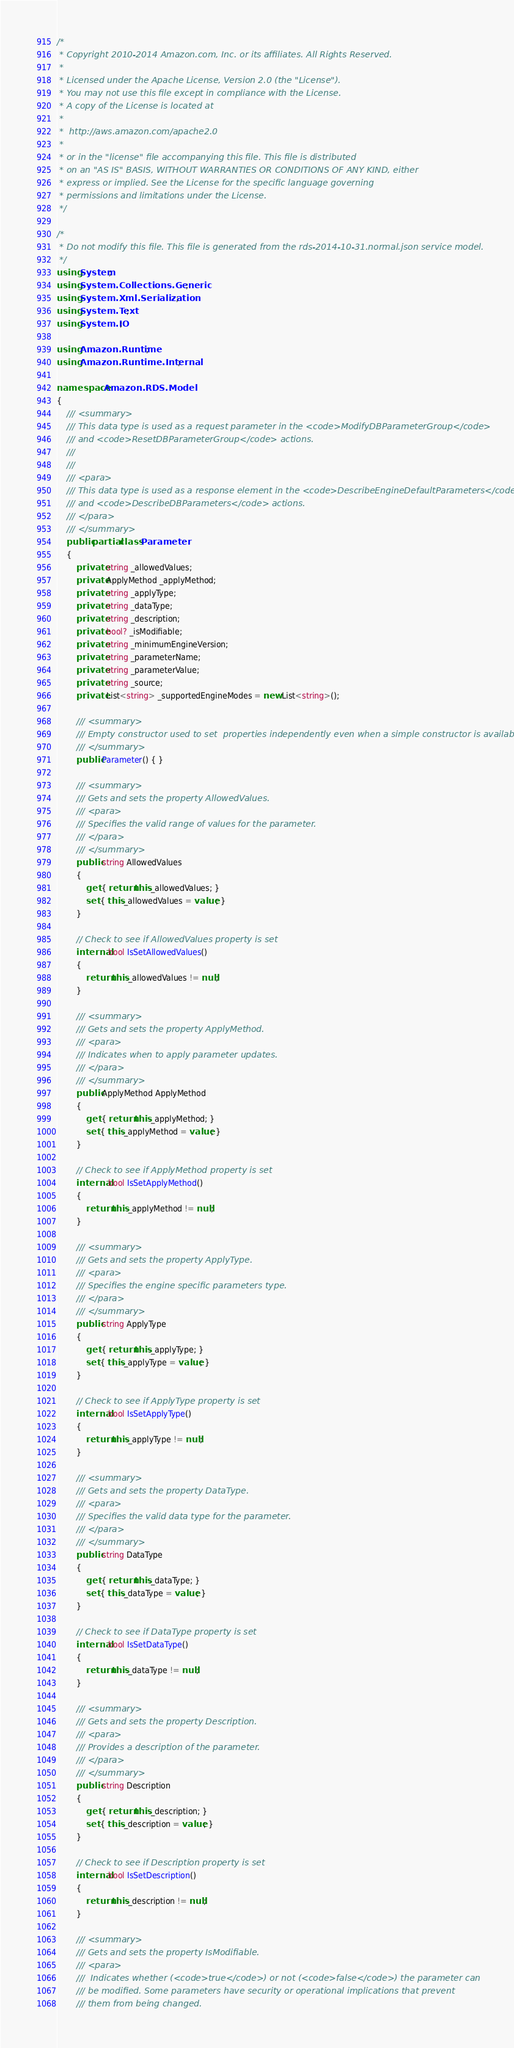<code> <loc_0><loc_0><loc_500><loc_500><_C#_>/*
 * Copyright 2010-2014 Amazon.com, Inc. or its affiliates. All Rights Reserved.
 * 
 * Licensed under the Apache License, Version 2.0 (the "License").
 * You may not use this file except in compliance with the License.
 * A copy of the License is located at
 * 
 *  http://aws.amazon.com/apache2.0
 * 
 * or in the "license" file accompanying this file. This file is distributed
 * on an "AS IS" BASIS, WITHOUT WARRANTIES OR CONDITIONS OF ANY KIND, either
 * express or implied. See the License for the specific language governing
 * permissions and limitations under the License.
 */

/*
 * Do not modify this file. This file is generated from the rds-2014-10-31.normal.json service model.
 */
using System;
using System.Collections.Generic;
using System.Xml.Serialization;
using System.Text;
using System.IO;

using Amazon.Runtime;
using Amazon.Runtime.Internal;

namespace Amazon.RDS.Model
{
    /// <summary>
    /// This data type is used as a request parameter in the <code>ModifyDBParameterGroup</code>
    /// and <code>ResetDBParameterGroup</code> actions. 
    /// 
    ///  
    /// <para>
    /// This data type is used as a response element in the <code>DescribeEngineDefaultParameters</code>
    /// and <code>DescribeDBParameters</code> actions.
    /// </para>
    /// </summary>
    public partial class Parameter
    {
        private string _allowedValues;
        private ApplyMethod _applyMethod;
        private string _applyType;
        private string _dataType;
        private string _description;
        private bool? _isModifiable;
        private string _minimumEngineVersion;
        private string _parameterName;
        private string _parameterValue;
        private string _source;
        private List<string> _supportedEngineModes = new List<string>();

        /// <summary>
        /// Empty constructor used to set  properties independently even when a simple constructor is available
        /// </summary>
        public Parameter() { }

        /// <summary>
        /// Gets and sets the property AllowedValues. 
        /// <para>
        /// Specifies the valid range of values for the parameter.
        /// </para>
        /// </summary>
        public string AllowedValues
        {
            get { return this._allowedValues; }
            set { this._allowedValues = value; }
        }

        // Check to see if AllowedValues property is set
        internal bool IsSetAllowedValues()
        {
            return this._allowedValues != null;
        }

        /// <summary>
        /// Gets and sets the property ApplyMethod. 
        /// <para>
        /// Indicates when to apply parameter updates.
        /// </para>
        /// </summary>
        public ApplyMethod ApplyMethod
        {
            get { return this._applyMethod; }
            set { this._applyMethod = value; }
        }

        // Check to see if ApplyMethod property is set
        internal bool IsSetApplyMethod()
        {
            return this._applyMethod != null;
        }

        /// <summary>
        /// Gets and sets the property ApplyType. 
        /// <para>
        /// Specifies the engine specific parameters type.
        /// </para>
        /// </summary>
        public string ApplyType
        {
            get { return this._applyType; }
            set { this._applyType = value; }
        }

        // Check to see if ApplyType property is set
        internal bool IsSetApplyType()
        {
            return this._applyType != null;
        }

        /// <summary>
        /// Gets and sets the property DataType. 
        /// <para>
        /// Specifies the valid data type for the parameter.
        /// </para>
        /// </summary>
        public string DataType
        {
            get { return this._dataType; }
            set { this._dataType = value; }
        }

        // Check to see if DataType property is set
        internal bool IsSetDataType()
        {
            return this._dataType != null;
        }

        /// <summary>
        /// Gets and sets the property Description. 
        /// <para>
        /// Provides a description of the parameter.
        /// </para>
        /// </summary>
        public string Description
        {
            get { return this._description; }
            set { this._description = value; }
        }

        // Check to see if Description property is set
        internal bool IsSetDescription()
        {
            return this._description != null;
        }

        /// <summary>
        /// Gets and sets the property IsModifiable. 
        /// <para>
        ///  Indicates whether (<code>true</code>) or not (<code>false</code>) the parameter can
        /// be modified. Some parameters have security or operational implications that prevent
        /// them from being changed. </code> 